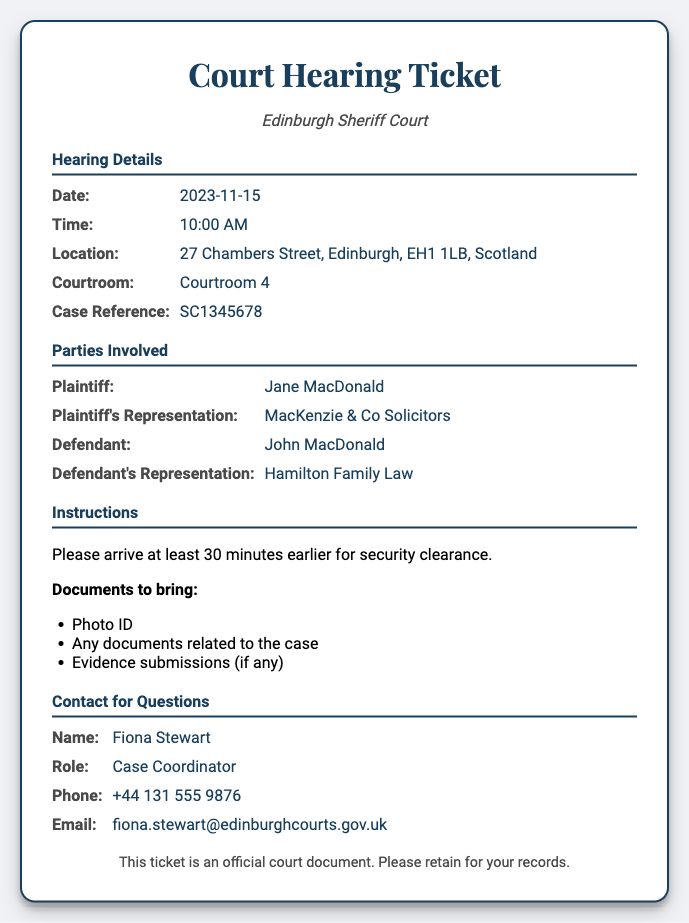What is the date of the hearing? The date of the hearing is specified in the document under "Date."
Answer: 2023-11-15 What time is the hearing scheduled? The time of the hearing is provided in the "Time" section of the document.
Answer: 10:00 AM Where is the hearing taking place? The location of the hearing can be found in the section labeled "Location."
Answer: 27 Chambers Street, Edinburgh, EH1 1LB, Scotland What is the case reference number? The case reference number is detailed under "Case Reference" in the hearing details.
Answer: SC1345678 Who is the Plaintiff in this case? The name of the Plaintiff is given in the "Parties Involved" section.
Answer: Jane MacDonald Which courtroom is specified for the hearing? The courtroom for the hearing is listed under "Courtroom" in the hearing details.
Answer: Courtroom 4 What is the name of the Case Coordinator? The document states the name of the contact person under "Contact for Questions."
Answer: Fiona Stewart What should attendees bring to the hearing? The document lists required items in the "Instructions" section.
Answer: Photo ID, Any documents related to the case, Evidence submissions (if any) How early should attendees arrive? The instruction regarding arrival time is specified clearly in the document.
Answer: 30 minutes earlier 